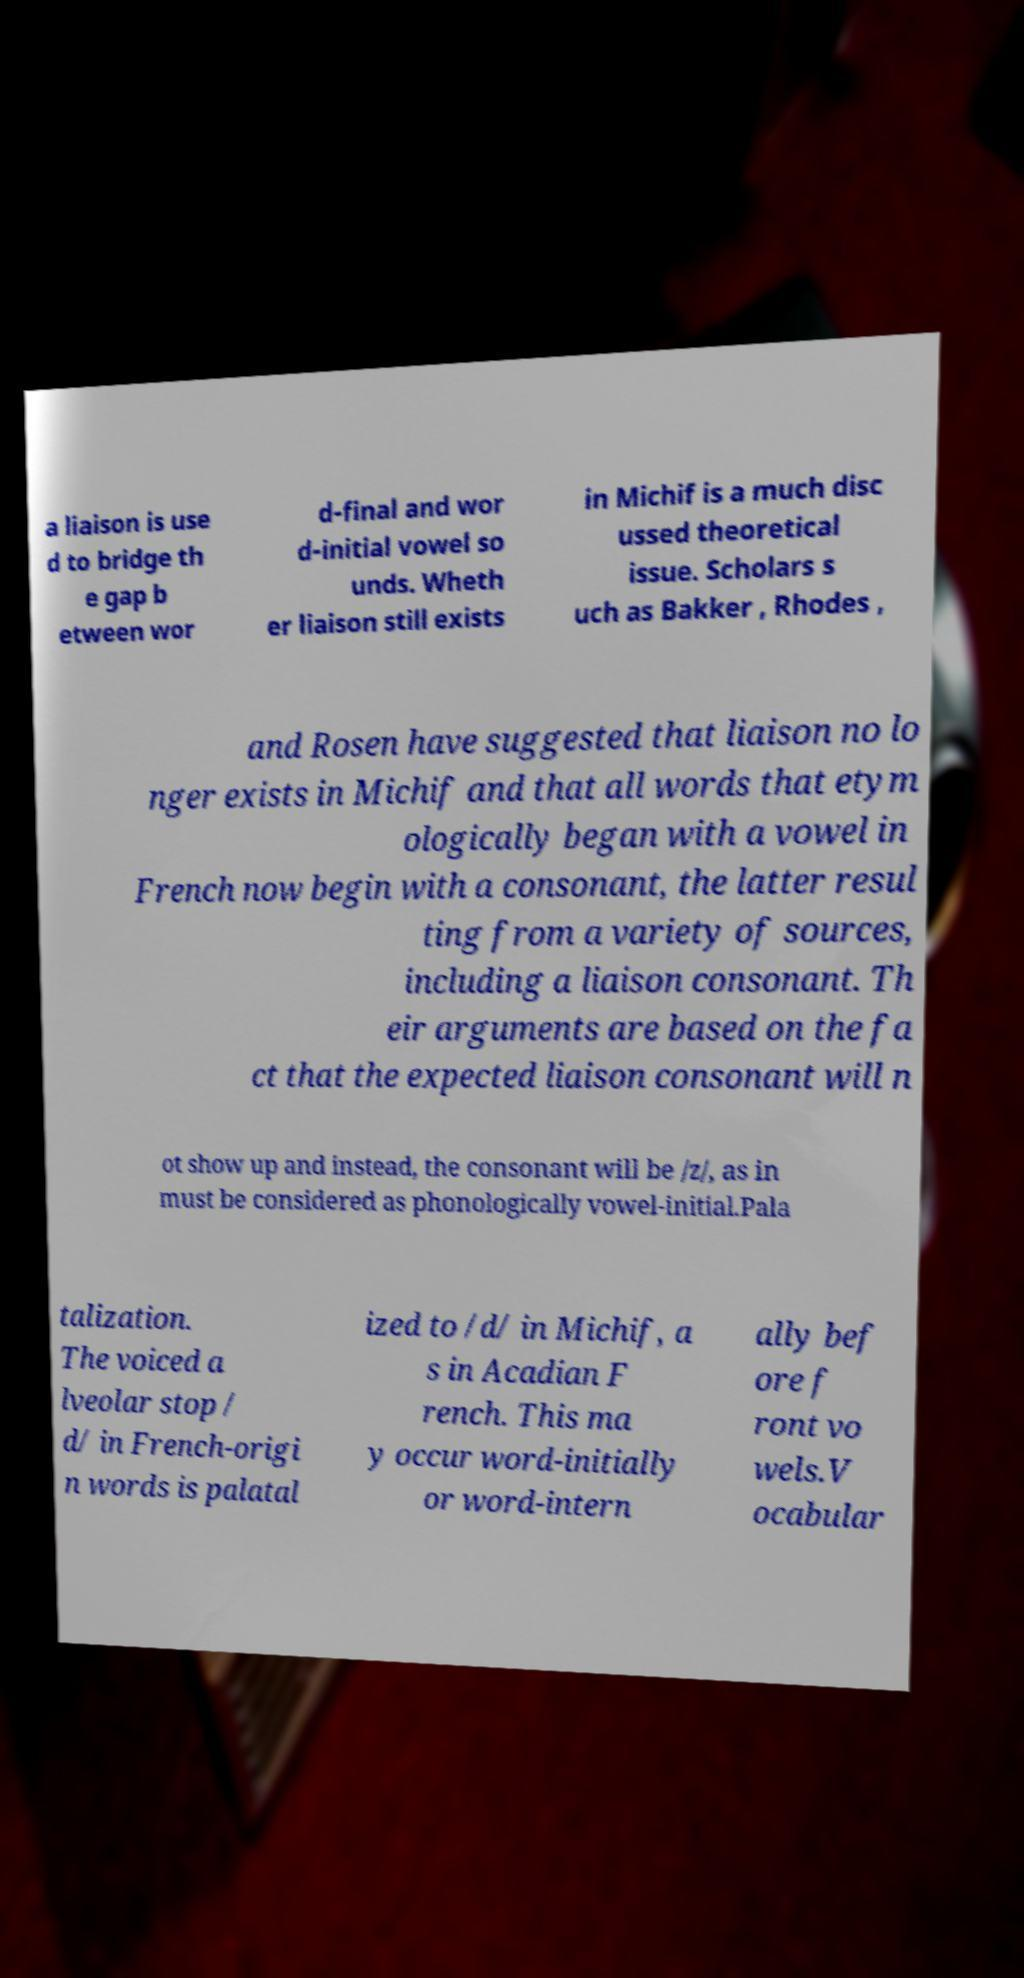For documentation purposes, I need the text within this image transcribed. Could you provide that? a liaison is use d to bridge th e gap b etween wor d-final and wor d-initial vowel so unds. Wheth er liaison still exists in Michif is a much disc ussed theoretical issue. Scholars s uch as Bakker , Rhodes , and Rosen have suggested that liaison no lo nger exists in Michif and that all words that etym ologically began with a vowel in French now begin with a consonant, the latter resul ting from a variety of sources, including a liaison consonant. Th eir arguments are based on the fa ct that the expected liaison consonant will n ot show up and instead, the consonant will be /z/, as in must be considered as phonologically vowel-initial.Pala talization. The voiced a lveolar stop / d/ in French-origi n words is palatal ized to /d/ in Michif, a s in Acadian F rench. This ma y occur word-initially or word-intern ally bef ore f ront vo wels.V ocabular 